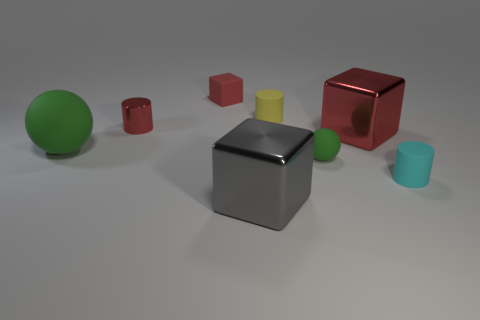There is a tiny cube that is the same color as the small metallic thing; what is its material?
Give a very brief answer. Rubber. Is the material of the yellow thing the same as the large gray block?
Provide a short and direct response. No. Is the number of large gray cubes that are on the left side of the tiny red matte block less than the number of purple matte objects?
Your answer should be very brief. No. What number of objects are big red rubber objects or matte balls that are to the left of the large gray cube?
Offer a very short reply. 1. The tiny ball that is the same material as the big green ball is what color?
Make the answer very short. Green. What number of objects are either large purple things or matte cylinders?
Ensure brevity in your answer.  2. The metallic thing that is the same size as the gray shiny cube is what color?
Offer a very short reply. Red. How many objects are green spheres on the right side of the red metal cylinder or tiny purple blocks?
Make the answer very short. 1. How many other things are the same size as the red metallic cylinder?
Give a very brief answer. 4. What size is the red matte thing that is behind the tiny green ball?
Keep it short and to the point. Small. 